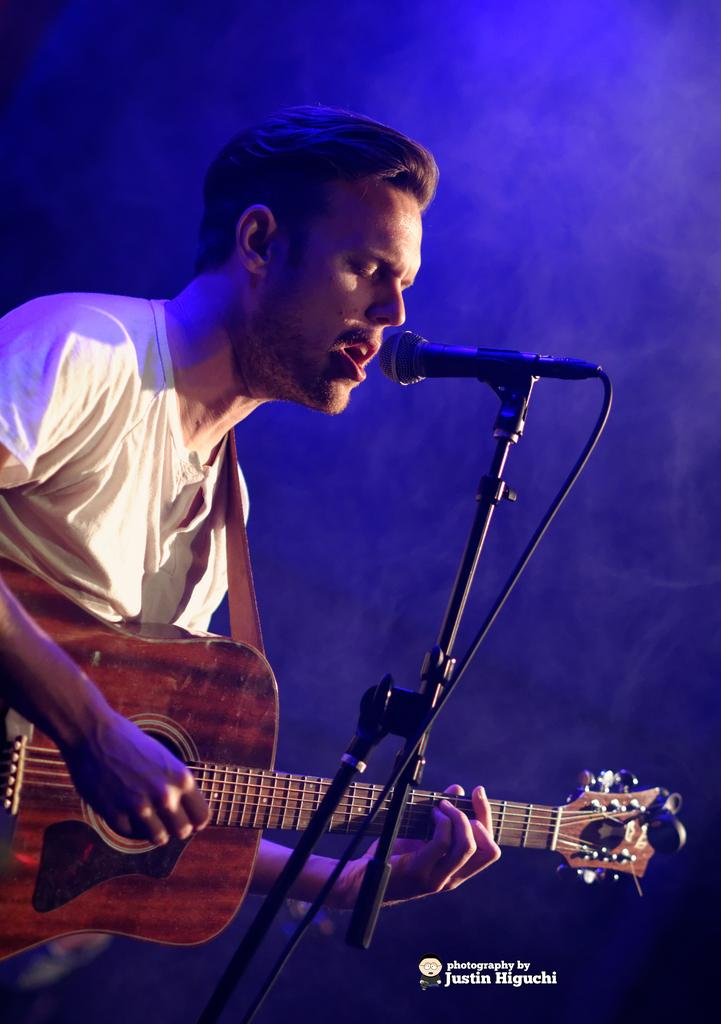What is the main subject of the image? There is a person in the image. What is the person wearing? The person is wearing a white t-shirt. What is the person doing in the image? The person is singing and playing the guitar. What is the person holding while playing the guitar? The person is holding a guitar. What is in front of the person to help with the singing? There is a microphone and a mic stand in front of the person. What type of square is depicted in the image? There is no square present in the image. What company does the person work for in the image? The image does not provide information about the person's employment or any company affiliation. 